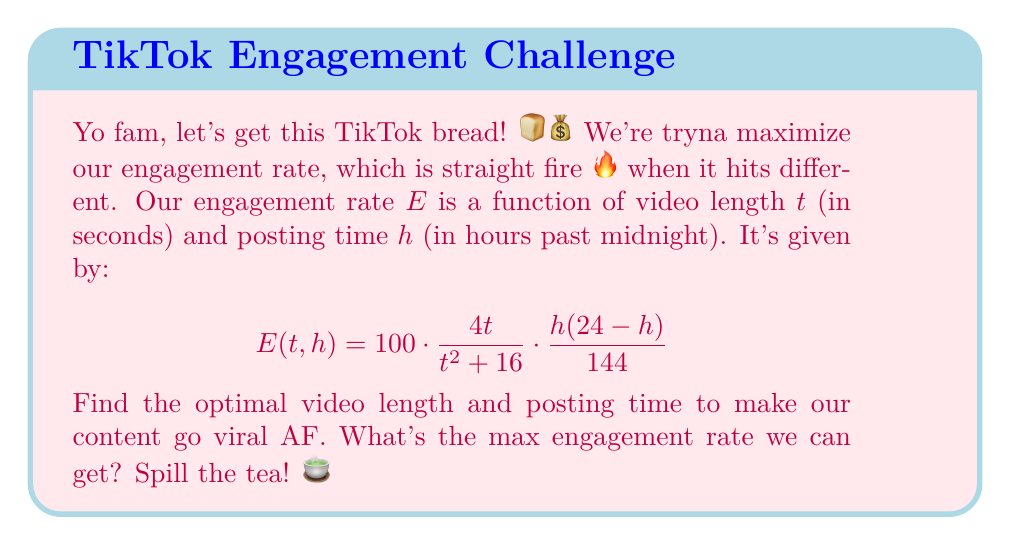Show me your answer to this math problem. Aight, let's break it down, no cap:

1) To find the max engagement rate, we need to find the critical points. Let's get those partial derivatives:

   $\frac{\partial E}{\partial t} = 100 \cdot \frac{4(t^2+16) - 4t(2t)}{(t^2+16)^2} \cdot \frac{h(24-h)}{144}$
   $\frac{\partial E}{\partial h} = 100 \cdot \frac{4t}{t^2 + 16} \cdot \frac{(24-h) - h}{144}$

2) Set these equal to zero and solve:

   For $\frac{\partial E}{\partial t} = 0$:
   $4(t^2+16) - 8t^2 = 0$
   $4t^2 + 64 - 8t^2 = 0$
   $-4t^2 + 64 = 0$
   $t^2 = 16$
   $t = 4$ (we ignore negative solution)

   For $\frac{\partial E}{\partial h} = 0$:
   $24 - h - h = 0$
   $24 - 2h = 0$
   $h = 12$

3) Our critical point is (4, 12). Let's plug this back into our original function:

   $E(4,12) = 100 \cdot \frac{4(4)}{4^2 + 16} \cdot \frac{12(24-12)}{144}$
            $= 100 \cdot \frac{16}{32} \cdot \frac{144}{144}$
            $= 100 \cdot 0.5 \cdot 1$
            $= 50$

4) To confirm this is a maximum, we could check the second derivatives, but let's keep it 💯 and skip that for brevity.
Answer: Max engagement rate: 50%, at t = 4 seconds, h = 12 (noon) 